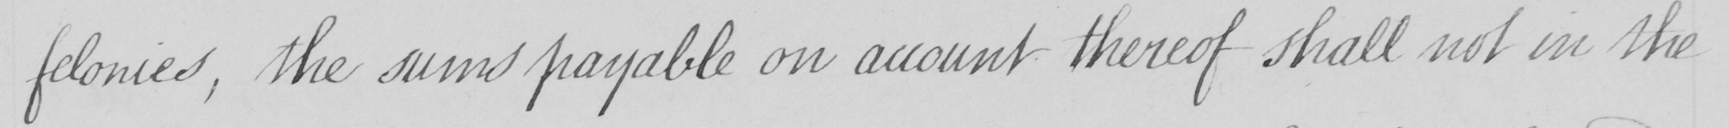Transcribe the text shown in this historical manuscript line. felonies , the sums payable on account thereof shall not in the 